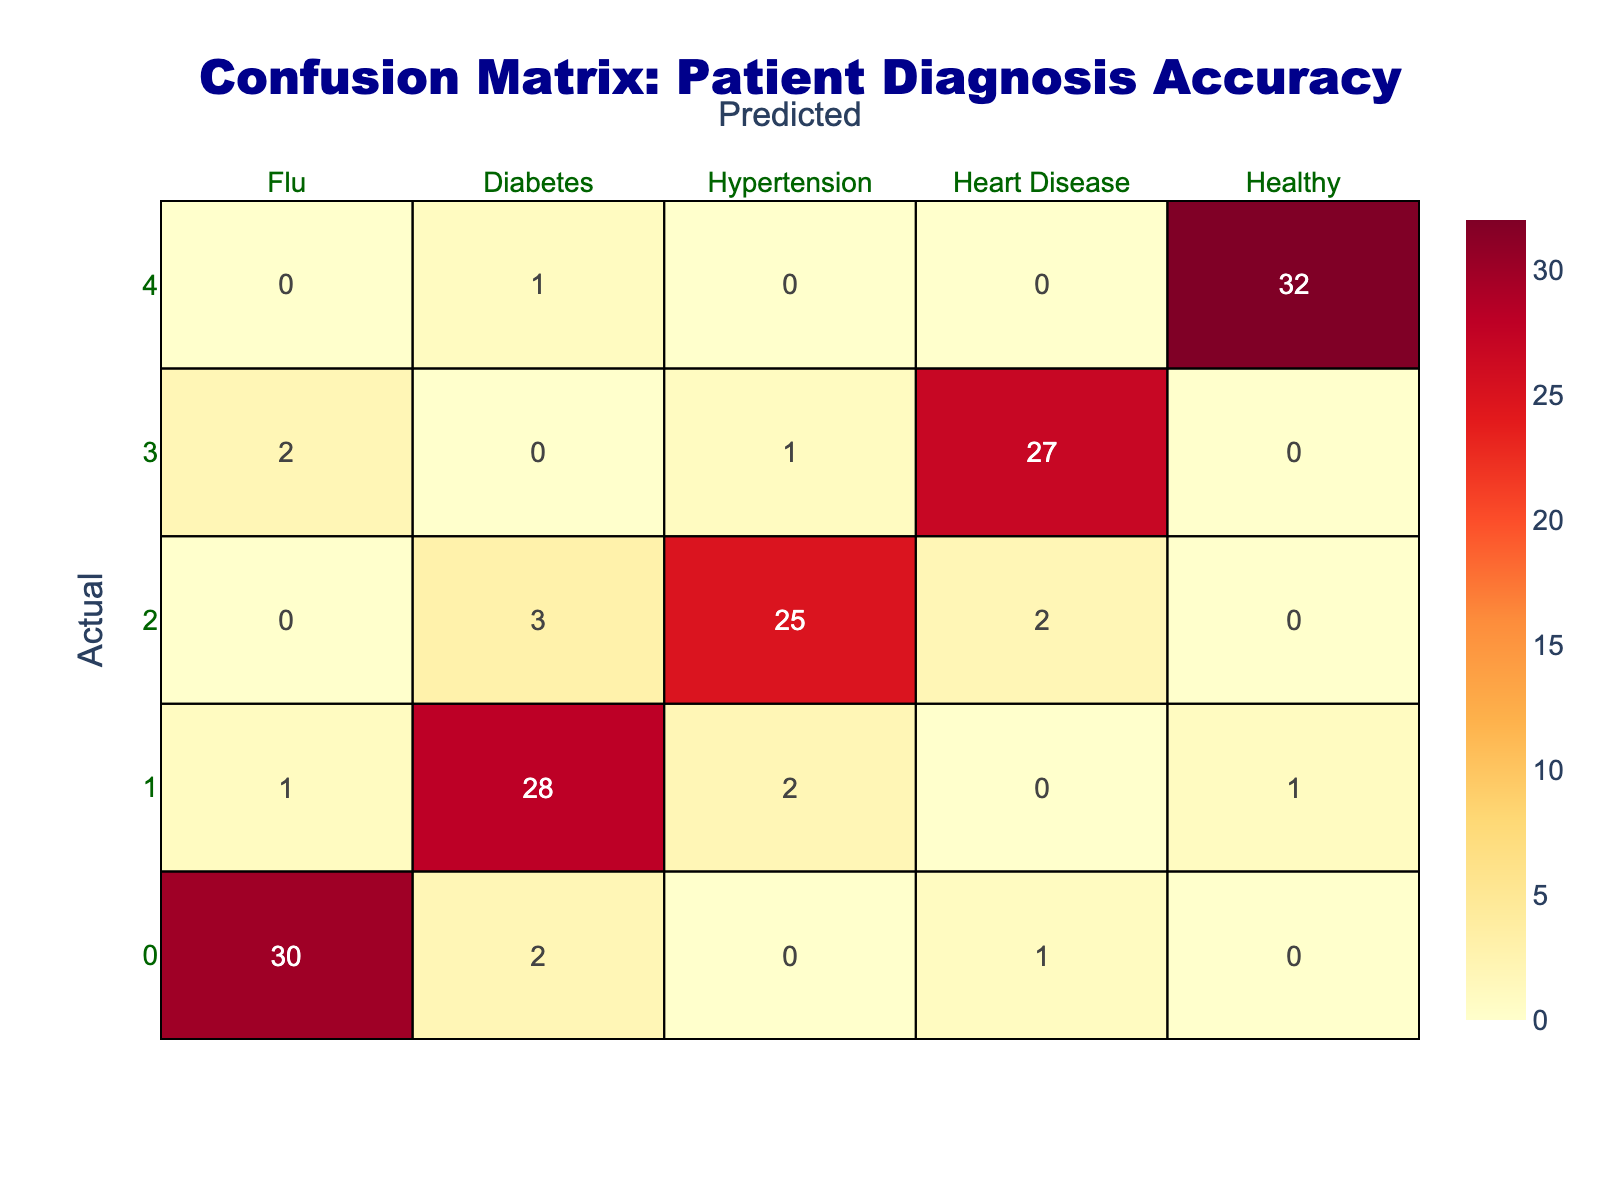What is the number of true positive diagnoses for diabetes? The true positive diagnoses for diabetes can be found in the intersection of the "Diabetes" row and the "Diabetes" column. From the table, this value is 28.
Answer: 28 What is the total number of patients who were incorrectly diagnosed with hypertension? To find the number of incorrect diagnoses for hypertension, I need to sum the values in the "Hypertension" row (not counting the true positive). This includes: 3 (false positive for flu) + 2 (false positive for diabetes) + 1 (false positive for heart disease) = 6.
Answer: 6 How many patients were correctly diagnosed as healthy? The correct diagnoses for healthy patients can be found in the intersection of the "Healthy" row and the "Healthy" column. It shows that there were 32 correct diagnoses.
Answer: 32 Is it true that more patients were falsely diagnosed with flu than with heart disease? To check this, I look at the number of patients falsely diagnosed as flu (total of 2 + 1 + 0 = 3) and compare it with those falsely diagnosed as heart disease (total of 2 + 0 + 0 = 2). Since 3 is greater than 2, the statement is true.
Answer: Yes What is the total number of patients diagnosed with heart disease? The total number diagnosed with heart disease can be obtained by summing all values in the "Heart Disease" column: 1 (true positive from flu) + 0 (true positive from diabetes) + 2 (true positive from hypertension) + 27 (true positive from heart disease) + 0 (true positive from healthy) = 30.
Answer: 30 What is the percentage of false negatives for diabetes? To find the false negatives for diabetes, I check the values in the "Diabetes" column that are not true positives. This includes 1 (false negative from flu) + 2 (false negative from hypertension) + 0 (false negative from heart disease) + 1 (false negative from healthy) = 4. The total actual patients diagnosed as diabetes is 30 (28 + 1 + 2 + 0 + 1). Therefore, the percentage of false negatives is (4 / 30) * 100 = 13.33%.
Answer: 13.33% What is the total number of diagnoses across all diseases? I find this by summing all the values in the table: 30 + 2 + 0 + 1 + 0 + 1 + 28 + 2 + 0 + 1 + 0 + 3 + 25 + 2 + 0 + 2 + 0 + 1 + 27 + 0 + 0 + 1 + 0 + 0 + 32 = 100.
Answer: 100 Are there any patients who were correctly diagnosed as having flu among those diagnosed as healthy? To answer this, I check the intersection of the "Flu" row with the "Healthy" column. The value there is 0, which means no patients were correctly diagnosed with flu among those diagnosed as healthy.
Answer: No What is the total number of incorrect diagnoses made? The total number of incorrect diagnoses can be calculated by considering the total of false positives and false negatives across all diseases. Adding each incorrect value gives (2 + 1 + 3 + 2 + 1 + 0 + 1 + 0 + 0 + 0 + 32) = 12. The total incorrect diagnoses then would be: (2+1) + (1+2) + 3 + (2) + (1) = 12.
Answer: 12 